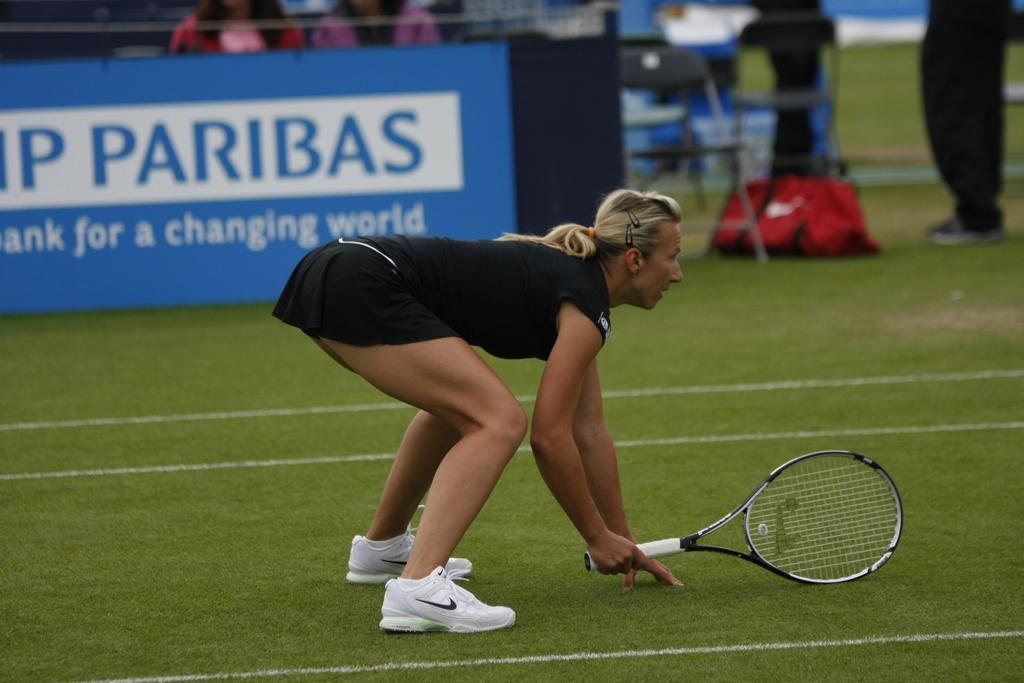What is the woman holding in the image? The woman is holding a bat. What can be seen in the background of the image? There are chairpersons standing and sitting in the background. What is featured in the image besides the woman and the chairpersons? There is a poster in the image. What type of sheet is being used by the actor in the image? There is no actor or sheet present in the image. What is the neck of the chairperson doing in the image? There is no specific focus on the neck of the chairpersons in the image; the image primarily shows them standing or sitting. 